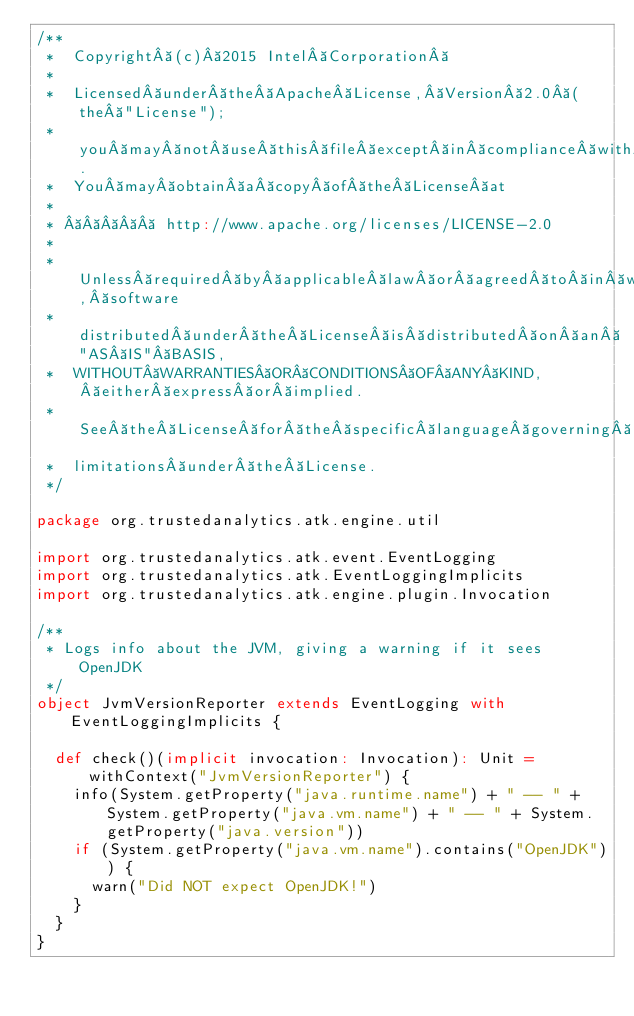Convert code to text. <code><loc_0><loc_0><loc_500><loc_500><_Scala_>/**
 *  Copyright (c) 2015 Intel Corporation 
 *
 *  Licensed under the Apache License, Version 2.0 (the "License");
 *  you may not use this file except in compliance with the License.
 *  You may obtain a copy of the License at
 *
 *       http://www.apache.org/licenses/LICENSE-2.0
 *
 *  Unless required by applicable law or agreed to in writing, software
 *  distributed under the License is distributed on an "AS IS" BASIS,
 *  WITHOUT WARRANTIES OR CONDITIONS OF ANY KIND, either express or implied.
 *  See the License for the specific language governing permissions and
 *  limitations under the License.
 */

package org.trustedanalytics.atk.engine.util

import org.trustedanalytics.atk.event.EventLogging
import org.trustedanalytics.atk.EventLoggingImplicits
import org.trustedanalytics.atk.engine.plugin.Invocation

/**
 * Logs info about the JVM, giving a warning if it sees OpenJDK
 */
object JvmVersionReporter extends EventLogging with EventLoggingImplicits {

  def check()(implicit invocation: Invocation): Unit = withContext("JvmVersionReporter") {
    info(System.getProperty("java.runtime.name") + " -- " + System.getProperty("java.vm.name") + " -- " + System.getProperty("java.version"))
    if (System.getProperty("java.vm.name").contains("OpenJDK")) {
      warn("Did NOT expect OpenJDK!")
    }
  }
}
</code> 